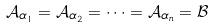<formula> <loc_0><loc_0><loc_500><loc_500>\mathcal { A } _ { \alpha _ { 1 } } = \mathcal { A } _ { \alpha _ { 2 } } = \cdots = \mathcal { A } _ { \alpha _ { n } } = \mathcal { B }</formula> 